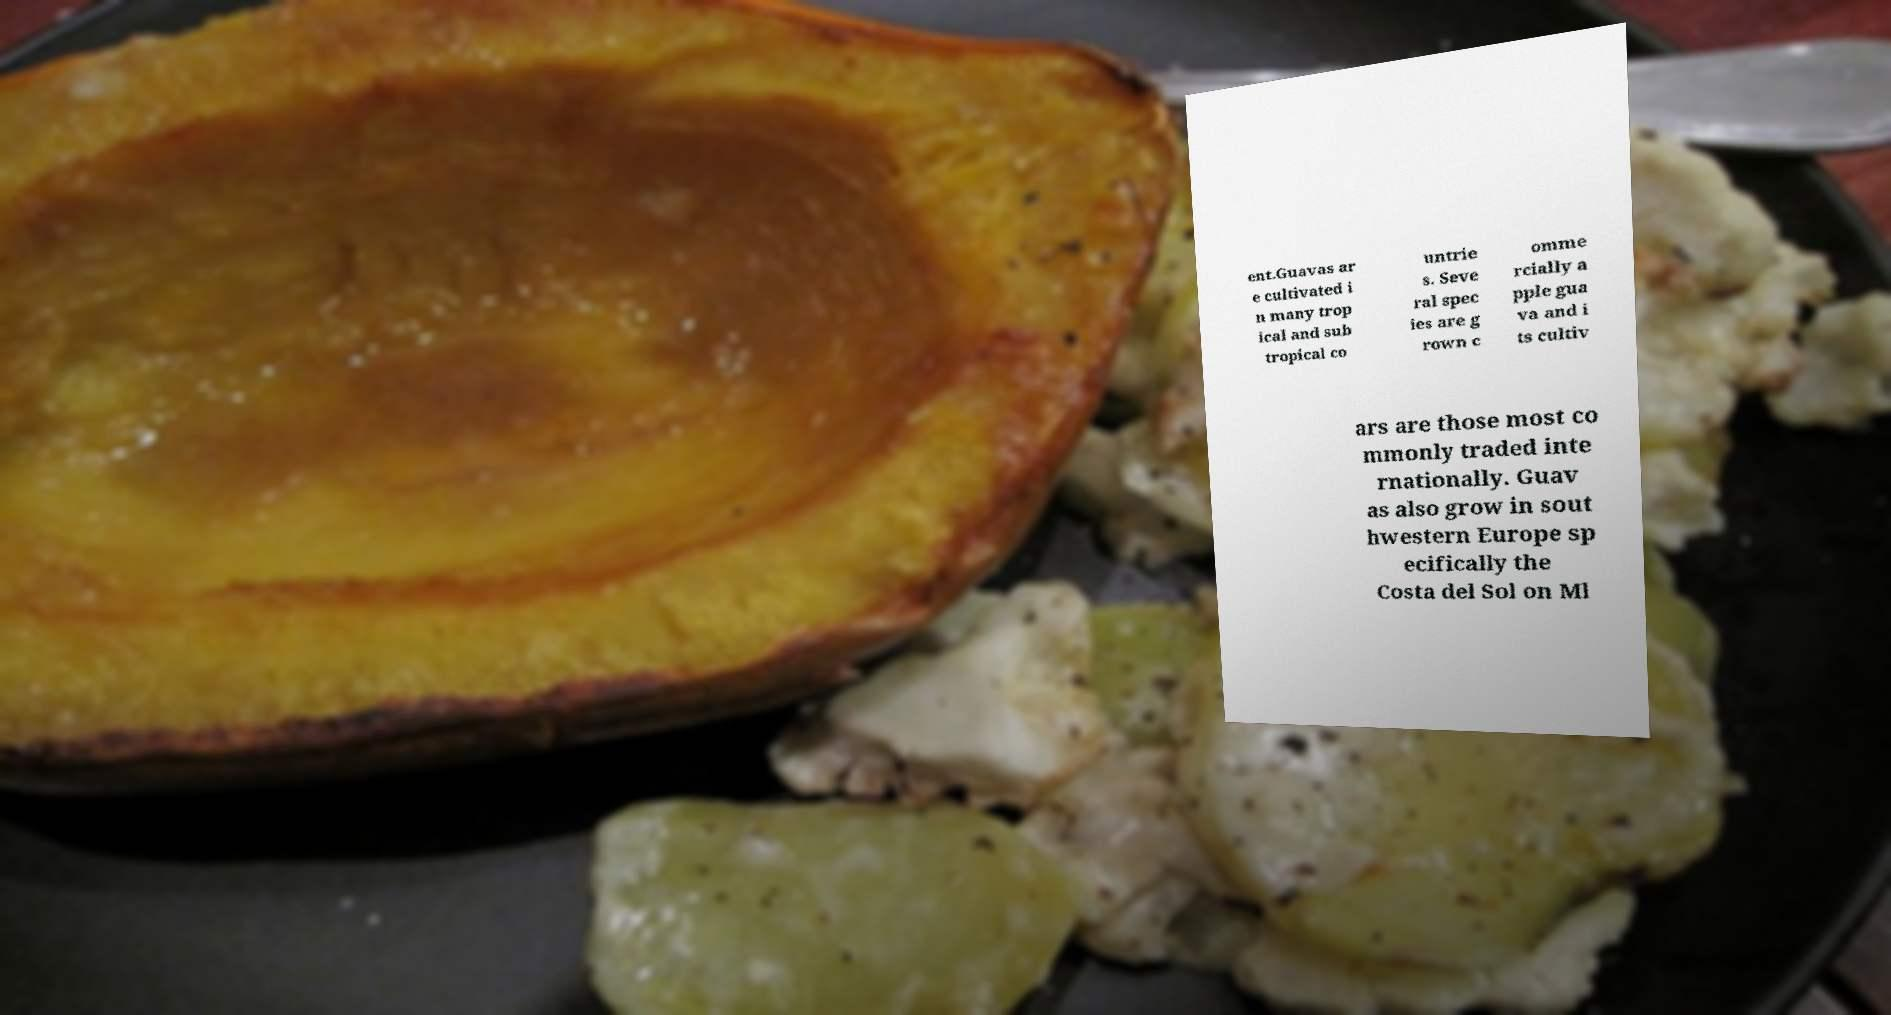Could you extract and type out the text from this image? ent.Guavas ar e cultivated i n many trop ical and sub tropical co untrie s. Seve ral spec ies are g rown c omme rcially a pple gua va and i ts cultiv ars are those most co mmonly traded inte rnationally. Guav as also grow in sout hwestern Europe sp ecifically the Costa del Sol on Ml 